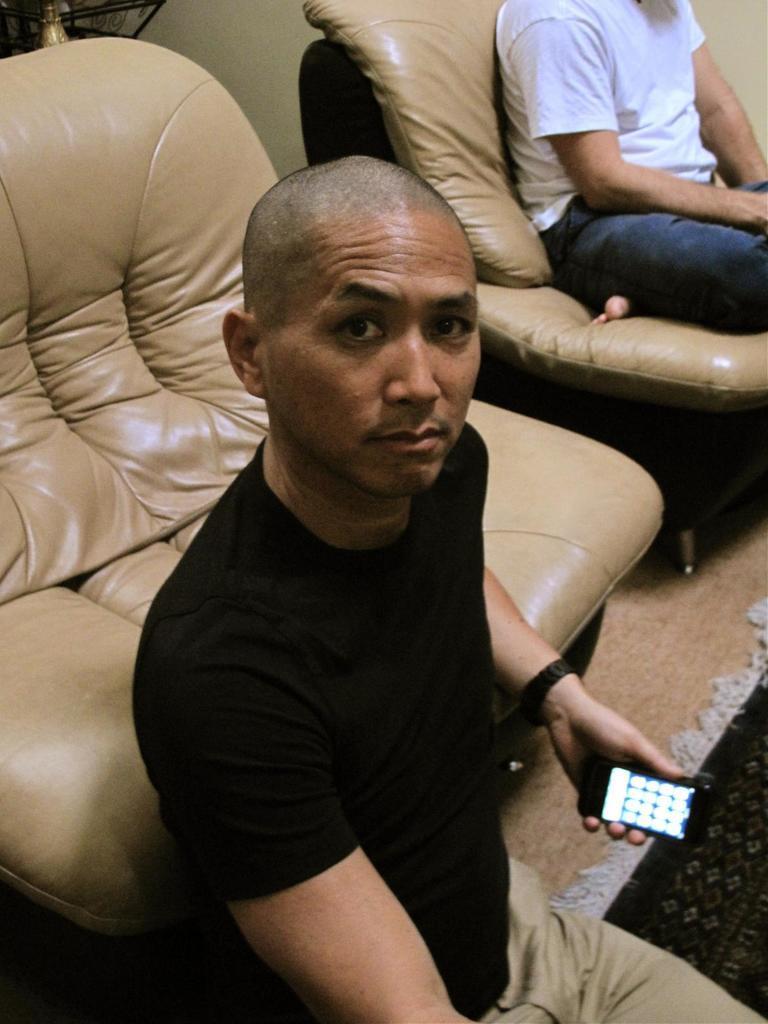Could you give a brief overview of what you see in this image? In this picture the man is sitting on the floor, holding a smartphone with his left hand and his looking at the person standing in front of him this the couch behind him and beside him there is another person sitting on the couch and there is a carpet on the floor 